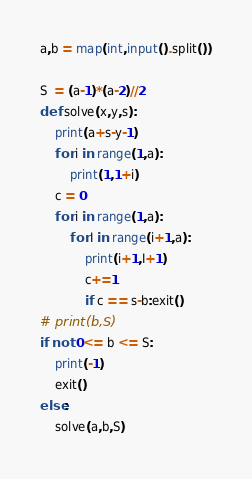<code> <loc_0><loc_0><loc_500><loc_500><_Python_>a,b = map(int,input().split())

S  = (a-1)*(a-2)//2
def solve(x,y,s):
    print(a+s-y-1)
    for i in range(1,a):
        print(1,1+i)
    c = 0
    for i in range(1,a):
        for I in range(i+1,a):
            print(i+1,I+1)
            c+=1
            if c == s-b:exit()
# print(b,S)
if not 0<= b <= S:
    print(-1)
    exit()
else:
    solve(a,b,S)
</code> 